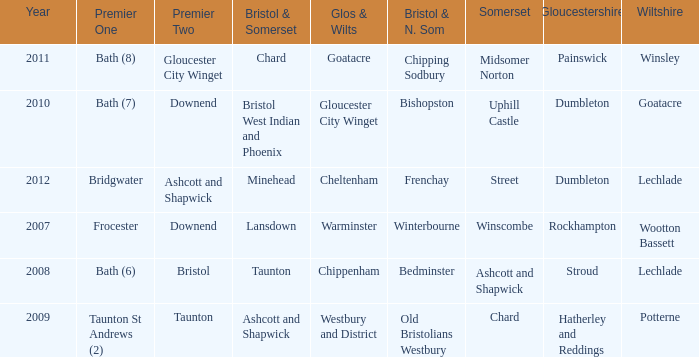What is the year where glos & wilts is gloucester city winget? 2010.0. 